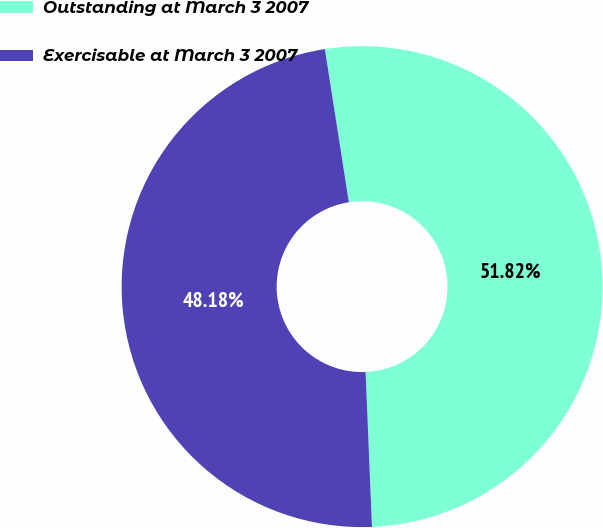Convert chart to OTSL. <chart><loc_0><loc_0><loc_500><loc_500><pie_chart><fcel>Outstanding at March 3 2007<fcel>Exercisable at March 3 2007<nl><fcel>51.82%<fcel>48.18%<nl></chart> 